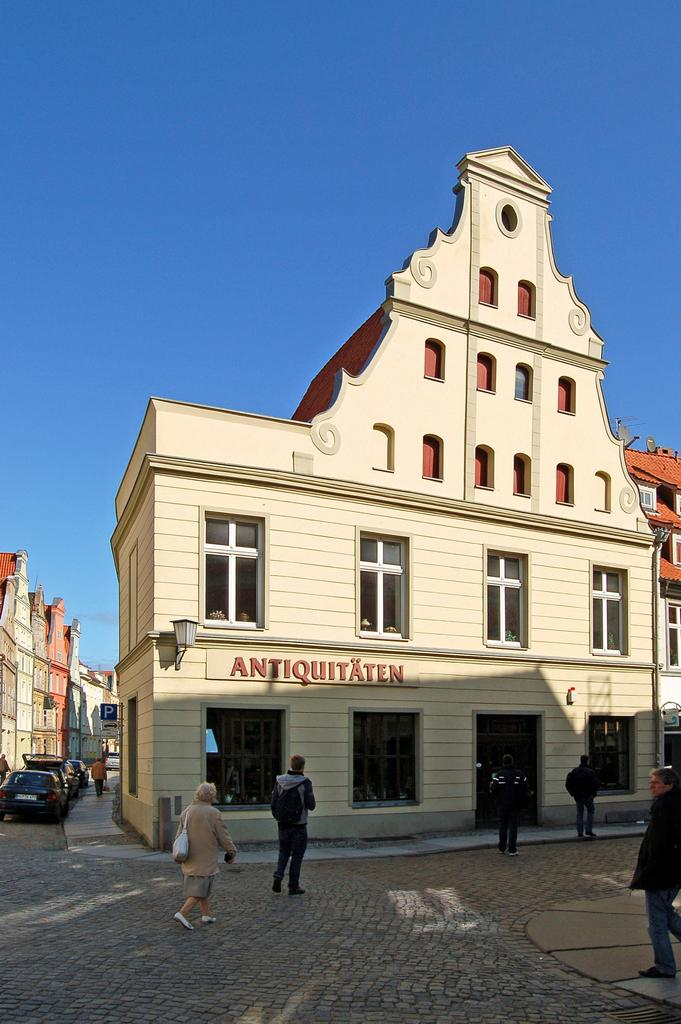<image>
Describe the image concisely. German market street with a shop that reads ANTIQUITAEN. 